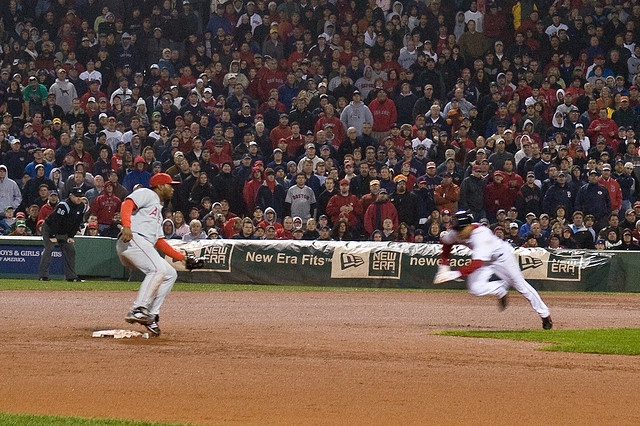Describe the objects in this image and their specific colors. I can see people in black, gray, and maroon tones, people in black, lightgray, darkgray, and gray tones, people in black, lavender, darkgray, and maroon tones, people in black, maroon, and brown tones, and people in black, maroon, and gray tones in this image. 